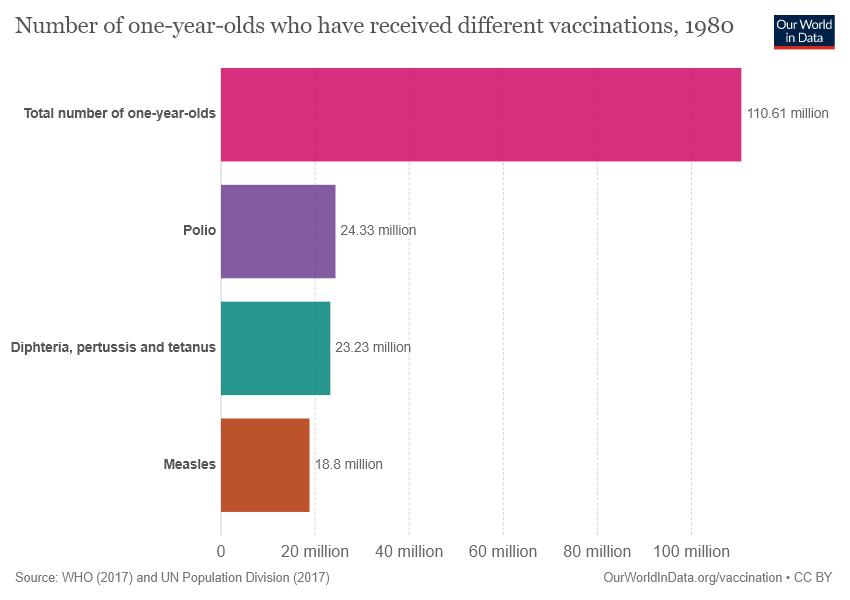Mention a couple of crucial points in this snapshot. Polio data is a specific set of numerical values, represented as 24.33... The percentage of one-year-olds affected by polio is 0.21996202874966095... 